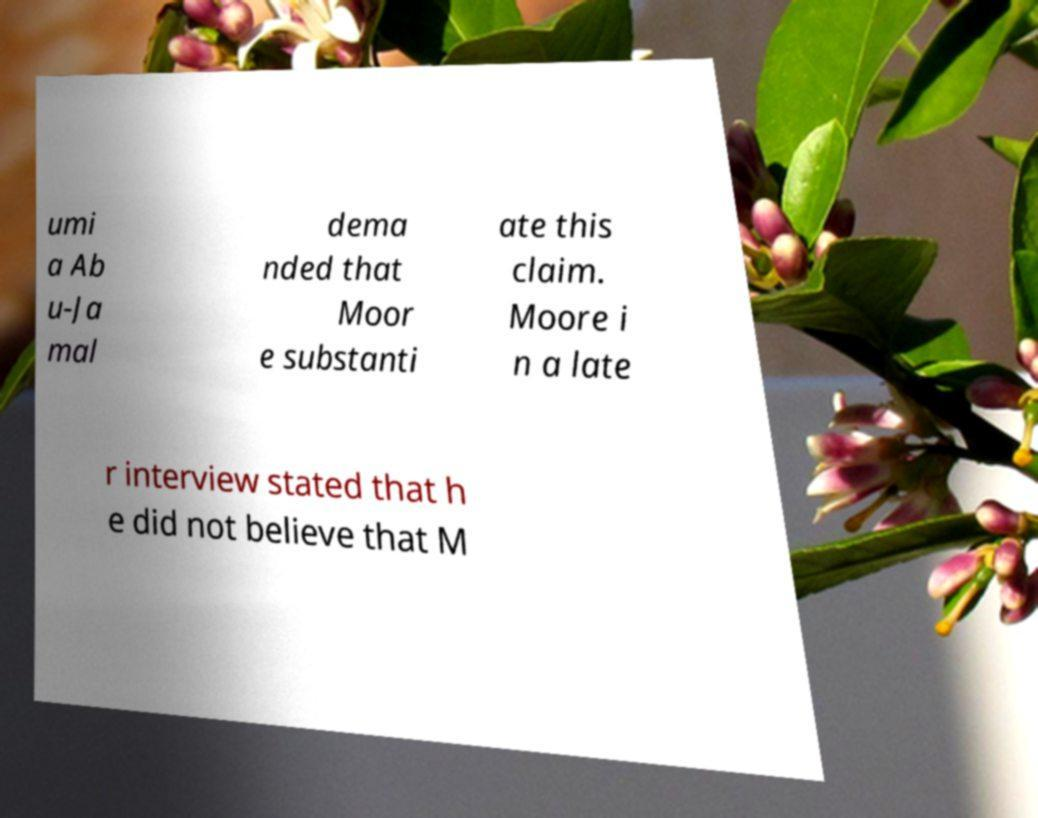What messages or text are displayed in this image? I need them in a readable, typed format. umi a Ab u-Ja mal dema nded that Moor e substanti ate this claim. Moore i n a late r interview stated that h e did not believe that M 